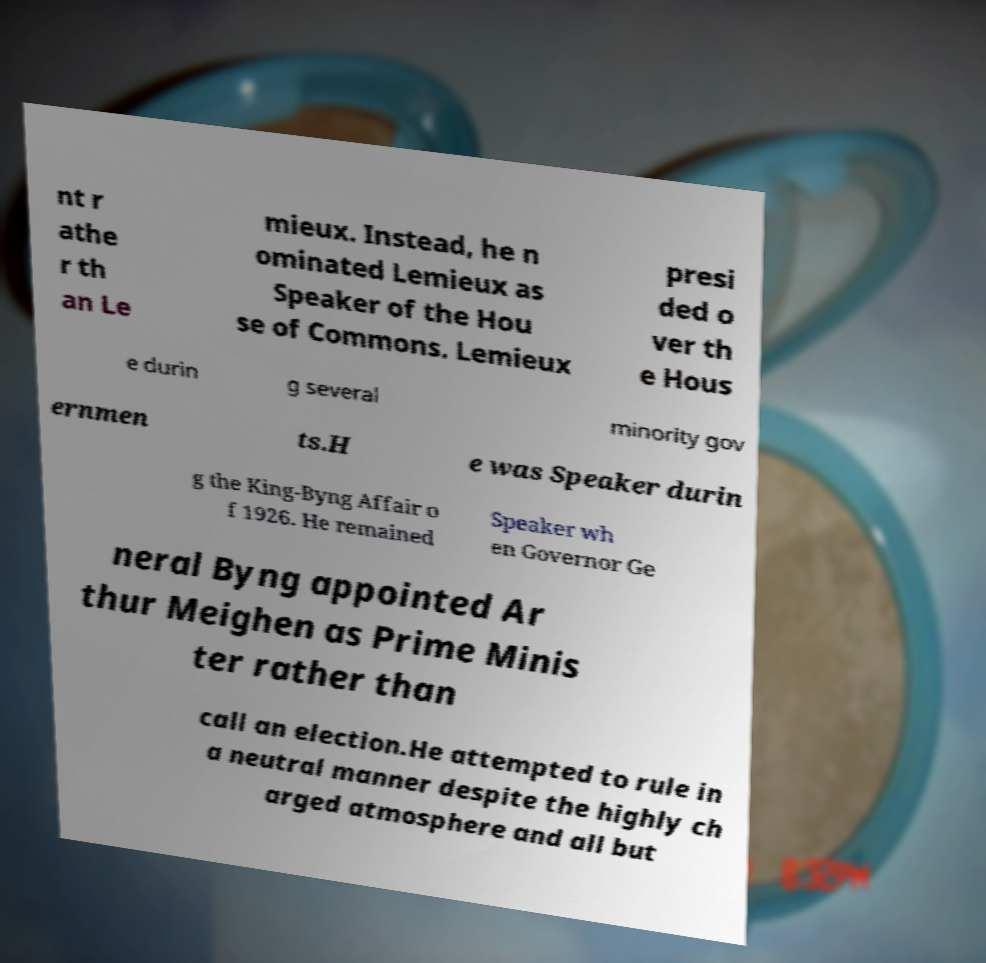What messages or text are displayed in this image? I need them in a readable, typed format. nt r athe r th an Le mieux. Instead, he n ominated Lemieux as Speaker of the Hou se of Commons. Lemieux presi ded o ver th e Hous e durin g several minority gov ernmen ts.H e was Speaker durin g the King-Byng Affair o f 1926. He remained Speaker wh en Governor Ge neral Byng appointed Ar thur Meighen as Prime Minis ter rather than call an election.He attempted to rule in a neutral manner despite the highly ch arged atmosphere and all but 